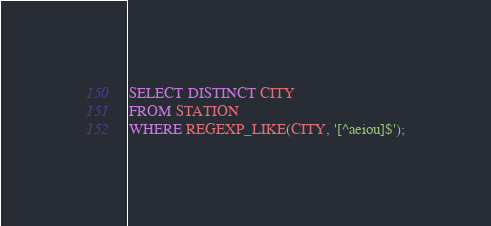Convert code to text. <code><loc_0><loc_0><loc_500><loc_500><_SQL_>SELECT DISTINCT CITY
FROM STATION
WHERE REGEXP_LIKE(CITY, '[^aeiou]$');</code> 